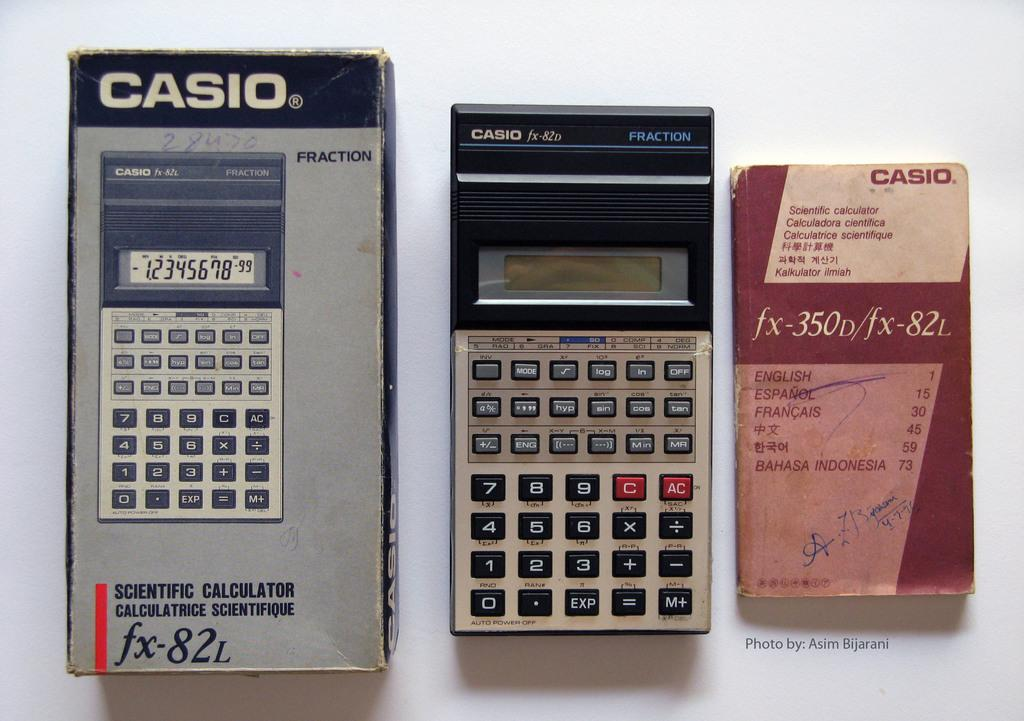<image>
Share a concise interpretation of the image provided. An older model CASIO fx-82L calculator with an instruction book. 